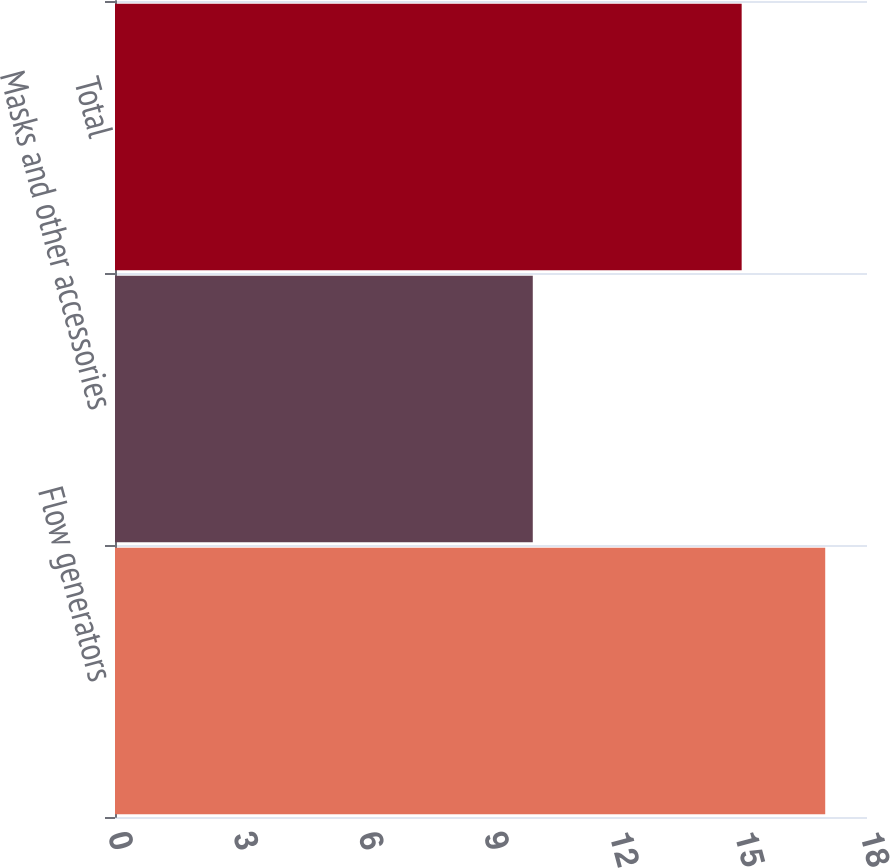Convert chart. <chart><loc_0><loc_0><loc_500><loc_500><bar_chart><fcel>Flow generators<fcel>Masks and other accessories<fcel>Total<nl><fcel>17<fcel>10<fcel>15<nl></chart> 